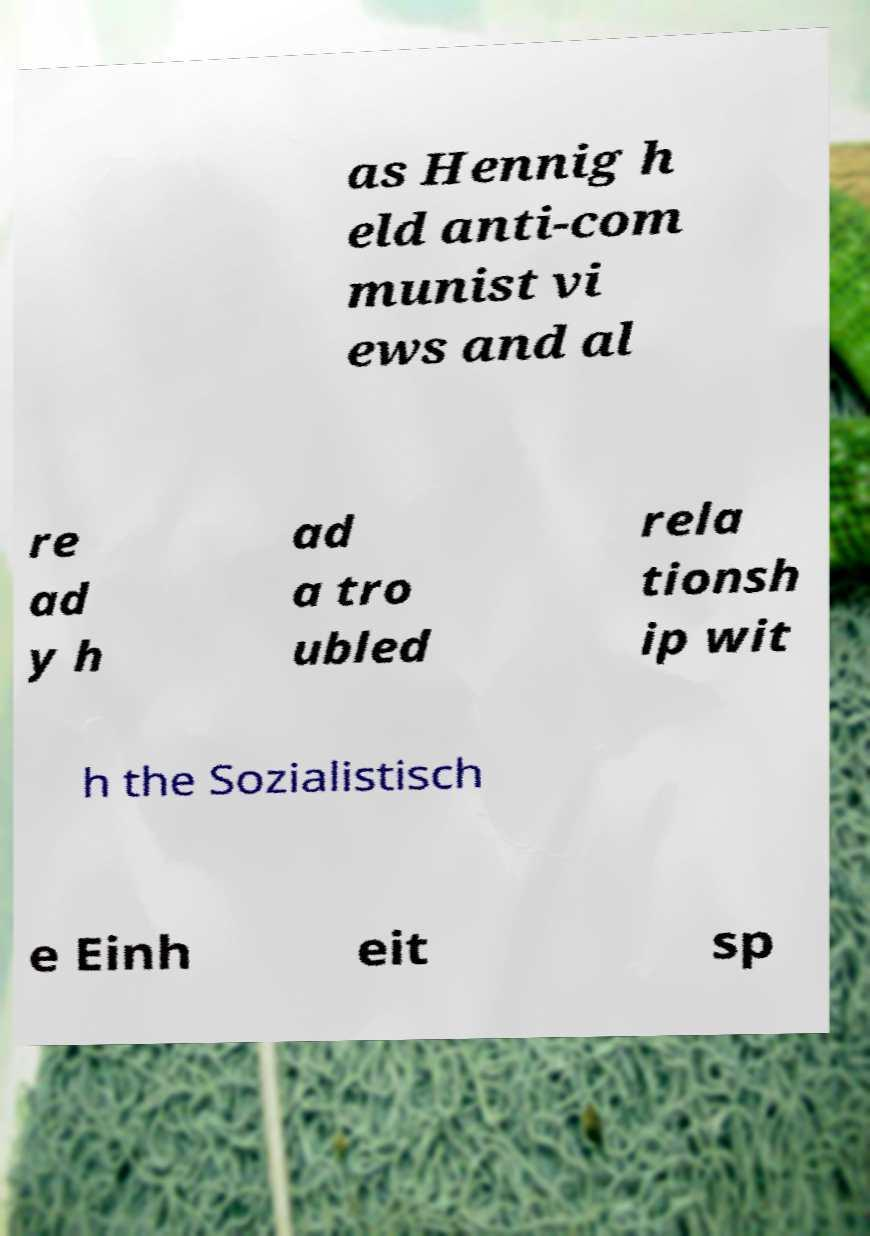Can you read and provide the text displayed in the image?This photo seems to have some interesting text. Can you extract and type it out for me? as Hennig h eld anti-com munist vi ews and al re ad y h ad a tro ubled rela tionsh ip wit h the Sozialistisch e Einh eit sp 